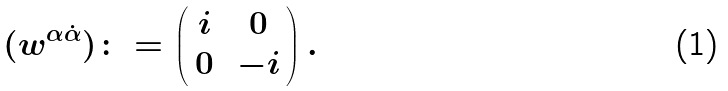<formula> <loc_0><loc_0><loc_500><loc_500>( w ^ { \alpha \dot { \alpha } } ) \colon = \begin{pmatrix} \, i & \, 0 \, \\ \, 0 & \, - i \, \end{pmatrix} .</formula> 